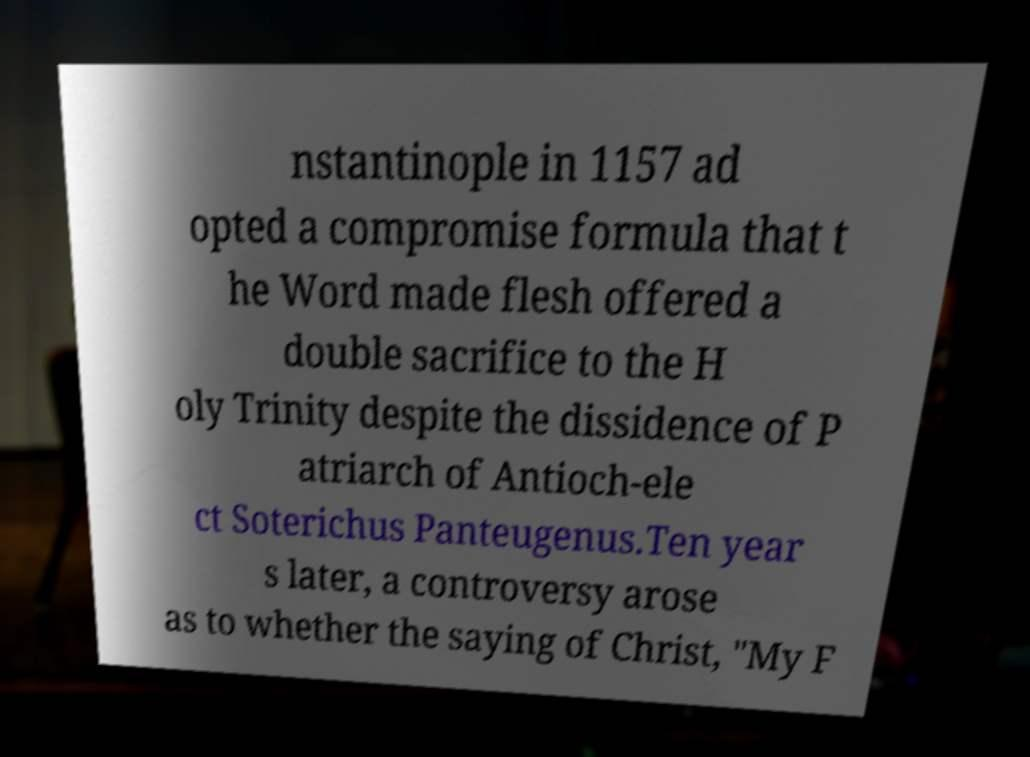What messages or text are displayed in this image? I need them in a readable, typed format. nstantinople in 1157 ad opted a compromise formula that t he Word made flesh offered a double sacrifice to the H oly Trinity despite the dissidence of P atriarch of Antioch-ele ct Soterichus Panteugenus.Ten year s later, a controversy arose as to whether the saying of Christ, "My F 